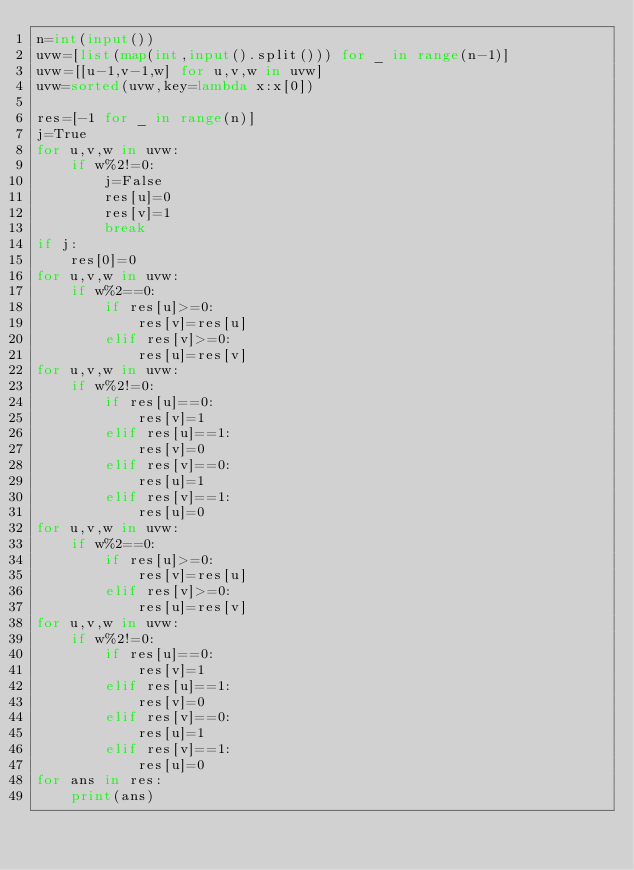<code> <loc_0><loc_0><loc_500><loc_500><_Python_>n=int(input())
uvw=[list(map(int,input().split())) for _ in range(n-1)]
uvw=[[u-1,v-1,w] for u,v,w in uvw]
uvw=sorted(uvw,key=lambda x:x[0])

res=[-1 for _ in range(n)]
j=True
for u,v,w in uvw:
    if w%2!=0:
        j=False
        res[u]=0
        res[v]=1
        break
if j:
    res[0]=0
for u,v,w in uvw:
    if w%2==0:
        if res[u]>=0:
            res[v]=res[u]
        elif res[v]>=0:
            res[u]=res[v]
for u,v,w in uvw:
    if w%2!=0:
        if res[u]==0:
            res[v]=1
        elif res[u]==1:
            res[v]=0
        elif res[v]==0:
            res[u]=1
        elif res[v]==1:
            res[u]=0
for u,v,w in uvw:
    if w%2==0:
        if res[u]>=0:
            res[v]=res[u]
        elif res[v]>=0:
            res[u]=res[v]
for u,v,w in uvw:
    if w%2!=0:
        if res[u]==0:
            res[v]=1
        elif res[u]==1:
            res[v]=0
        elif res[v]==0:
            res[u]=1
        elif res[v]==1:
            res[u]=0
for ans in res:
    print(ans)</code> 